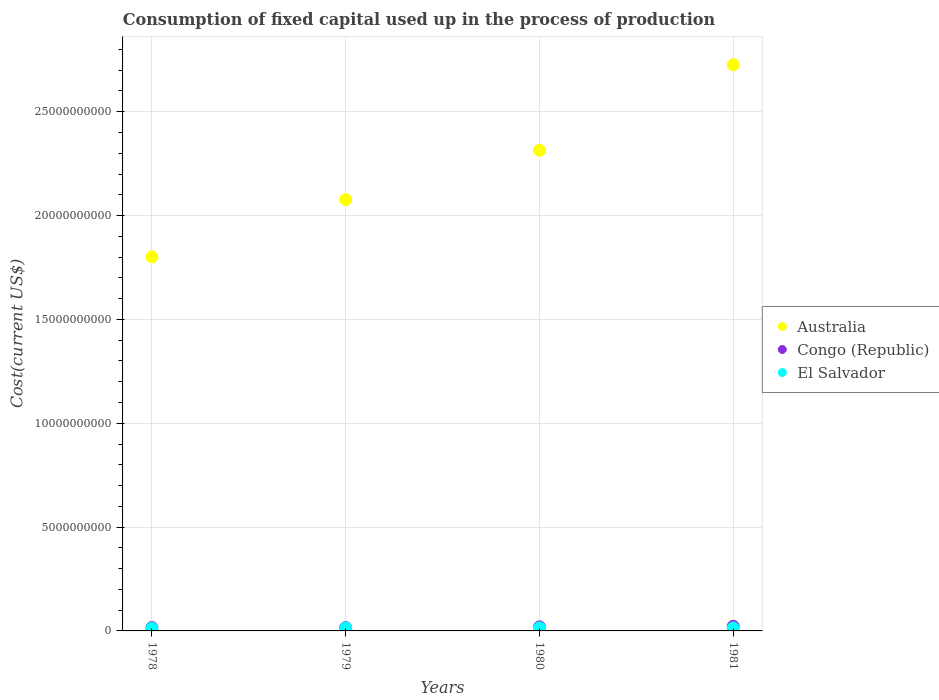Is the number of dotlines equal to the number of legend labels?
Ensure brevity in your answer.  Yes. What is the amount consumed in the process of production in Australia in 1980?
Your answer should be very brief. 2.31e+1. Across all years, what is the maximum amount consumed in the process of production in Australia?
Offer a terse response. 2.73e+1. Across all years, what is the minimum amount consumed in the process of production in Congo (Republic)?
Offer a very short reply. 1.60e+08. In which year was the amount consumed in the process of production in Australia maximum?
Keep it short and to the point. 1981. In which year was the amount consumed in the process of production in El Salvador minimum?
Keep it short and to the point. 1978. What is the total amount consumed in the process of production in Australia in the graph?
Make the answer very short. 8.92e+1. What is the difference between the amount consumed in the process of production in El Salvador in 1979 and that in 1980?
Keep it short and to the point. -4.63e+06. What is the difference between the amount consumed in the process of production in Congo (Republic) in 1981 and the amount consumed in the process of production in Australia in 1980?
Give a very brief answer. -2.29e+1. What is the average amount consumed in the process of production in Australia per year?
Make the answer very short. 2.23e+1. In the year 1979, what is the difference between the amount consumed in the process of production in El Salvador and amount consumed in the process of production in Congo (Republic)?
Provide a succinct answer. -1.71e+07. In how many years, is the amount consumed in the process of production in Australia greater than 10000000000 US$?
Your answer should be compact. 4. What is the ratio of the amount consumed in the process of production in El Salvador in 1978 to that in 1980?
Ensure brevity in your answer.  0.87. Is the difference between the amount consumed in the process of production in El Salvador in 1978 and 1980 greater than the difference between the amount consumed in the process of production in Congo (Republic) in 1978 and 1980?
Make the answer very short. Yes. What is the difference between the highest and the second highest amount consumed in the process of production in El Salvador?
Make the answer very short. 4.63e+06. What is the difference between the highest and the lowest amount consumed in the process of production in Australia?
Provide a short and direct response. 9.25e+09. In how many years, is the amount consumed in the process of production in El Salvador greater than the average amount consumed in the process of production in El Salvador taken over all years?
Provide a short and direct response. 3. Is it the case that in every year, the sum of the amount consumed in the process of production in Congo (Republic) and amount consumed in the process of production in El Salvador  is greater than the amount consumed in the process of production in Australia?
Offer a terse response. No. Is the amount consumed in the process of production in Australia strictly greater than the amount consumed in the process of production in El Salvador over the years?
Ensure brevity in your answer.  Yes. Is the amount consumed in the process of production in Australia strictly less than the amount consumed in the process of production in Congo (Republic) over the years?
Provide a short and direct response. No. How many years are there in the graph?
Provide a short and direct response. 4. Does the graph contain any zero values?
Make the answer very short. No. Where does the legend appear in the graph?
Offer a very short reply. Center right. How many legend labels are there?
Make the answer very short. 3. What is the title of the graph?
Keep it short and to the point. Consumption of fixed capital used up in the process of production. Does "East Asia (developing only)" appear as one of the legend labels in the graph?
Provide a short and direct response. No. What is the label or title of the Y-axis?
Your answer should be very brief. Cost(current US$). What is the Cost(current US$) in Australia in 1978?
Ensure brevity in your answer.  1.80e+1. What is the Cost(current US$) in Congo (Republic) in 1978?
Provide a short and direct response. 1.62e+08. What is the Cost(current US$) of El Salvador in 1978?
Your answer should be very brief. 1.29e+08. What is the Cost(current US$) in Australia in 1979?
Your answer should be compact. 2.08e+1. What is the Cost(current US$) in Congo (Republic) in 1979?
Your answer should be compact. 1.60e+08. What is the Cost(current US$) in El Salvador in 1979?
Your response must be concise. 1.43e+08. What is the Cost(current US$) in Australia in 1980?
Keep it short and to the point. 2.31e+1. What is the Cost(current US$) in Congo (Republic) in 1980?
Keep it short and to the point. 1.95e+08. What is the Cost(current US$) of El Salvador in 1980?
Make the answer very short. 1.48e+08. What is the Cost(current US$) of Australia in 1981?
Give a very brief answer. 2.73e+1. What is the Cost(current US$) in Congo (Republic) in 1981?
Offer a very short reply. 2.22e+08. What is the Cost(current US$) of El Salvador in 1981?
Offer a very short reply. 1.42e+08. Across all years, what is the maximum Cost(current US$) of Australia?
Provide a succinct answer. 2.73e+1. Across all years, what is the maximum Cost(current US$) in Congo (Republic)?
Provide a succinct answer. 2.22e+08. Across all years, what is the maximum Cost(current US$) of El Salvador?
Your answer should be compact. 1.48e+08. Across all years, what is the minimum Cost(current US$) in Australia?
Provide a short and direct response. 1.80e+1. Across all years, what is the minimum Cost(current US$) in Congo (Republic)?
Ensure brevity in your answer.  1.60e+08. Across all years, what is the minimum Cost(current US$) in El Salvador?
Your response must be concise. 1.29e+08. What is the total Cost(current US$) in Australia in the graph?
Give a very brief answer. 8.92e+1. What is the total Cost(current US$) of Congo (Republic) in the graph?
Your response must be concise. 7.39e+08. What is the total Cost(current US$) in El Salvador in the graph?
Your answer should be very brief. 5.63e+08. What is the difference between the Cost(current US$) in Australia in 1978 and that in 1979?
Provide a succinct answer. -2.76e+09. What is the difference between the Cost(current US$) in Congo (Republic) in 1978 and that in 1979?
Make the answer very short. 1.49e+06. What is the difference between the Cost(current US$) of El Salvador in 1978 and that in 1979?
Your response must be concise. -1.39e+07. What is the difference between the Cost(current US$) of Australia in 1978 and that in 1980?
Your response must be concise. -5.13e+09. What is the difference between the Cost(current US$) in Congo (Republic) in 1978 and that in 1980?
Your answer should be compact. -3.33e+07. What is the difference between the Cost(current US$) of El Salvador in 1978 and that in 1980?
Offer a terse response. -1.86e+07. What is the difference between the Cost(current US$) of Australia in 1978 and that in 1981?
Make the answer very short. -9.25e+09. What is the difference between the Cost(current US$) in Congo (Republic) in 1978 and that in 1981?
Give a very brief answer. -6.03e+07. What is the difference between the Cost(current US$) of El Salvador in 1978 and that in 1981?
Provide a succinct answer. -1.30e+07. What is the difference between the Cost(current US$) in Australia in 1979 and that in 1980?
Make the answer very short. -2.37e+09. What is the difference between the Cost(current US$) of Congo (Republic) in 1979 and that in 1980?
Make the answer very short. -3.48e+07. What is the difference between the Cost(current US$) of El Salvador in 1979 and that in 1980?
Provide a short and direct response. -4.63e+06. What is the difference between the Cost(current US$) in Australia in 1979 and that in 1981?
Offer a terse response. -6.49e+09. What is the difference between the Cost(current US$) of Congo (Republic) in 1979 and that in 1981?
Make the answer very short. -6.18e+07. What is the difference between the Cost(current US$) in El Salvador in 1979 and that in 1981?
Provide a short and direct response. 9.56e+05. What is the difference between the Cost(current US$) of Australia in 1980 and that in 1981?
Keep it short and to the point. -4.12e+09. What is the difference between the Cost(current US$) in Congo (Republic) in 1980 and that in 1981?
Make the answer very short. -2.69e+07. What is the difference between the Cost(current US$) of El Salvador in 1980 and that in 1981?
Give a very brief answer. 5.59e+06. What is the difference between the Cost(current US$) in Australia in 1978 and the Cost(current US$) in Congo (Republic) in 1979?
Your answer should be very brief. 1.79e+1. What is the difference between the Cost(current US$) of Australia in 1978 and the Cost(current US$) of El Salvador in 1979?
Your answer should be very brief. 1.79e+1. What is the difference between the Cost(current US$) in Congo (Republic) in 1978 and the Cost(current US$) in El Salvador in 1979?
Your answer should be very brief. 1.86e+07. What is the difference between the Cost(current US$) of Australia in 1978 and the Cost(current US$) of Congo (Republic) in 1980?
Ensure brevity in your answer.  1.78e+1. What is the difference between the Cost(current US$) of Australia in 1978 and the Cost(current US$) of El Salvador in 1980?
Provide a short and direct response. 1.79e+1. What is the difference between the Cost(current US$) of Congo (Republic) in 1978 and the Cost(current US$) of El Salvador in 1980?
Ensure brevity in your answer.  1.39e+07. What is the difference between the Cost(current US$) in Australia in 1978 and the Cost(current US$) in Congo (Republic) in 1981?
Offer a terse response. 1.78e+1. What is the difference between the Cost(current US$) in Australia in 1978 and the Cost(current US$) in El Salvador in 1981?
Make the answer very short. 1.79e+1. What is the difference between the Cost(current US$) of Congo (Republic) in 1978 and the Cost(current US$) of El Salvador in 1981?
Give a very brief answer. 1.95e+07. What is the difference between the Cost(current US$) in Australia in 1979 and the Cost(current US$) in Congo (Republic) in 1980?
Offer a terse response. 2.06e+1. What is the difference between the Cost(current US$) of Australia in 1979 and the Cost(current US$) of El Salvador in 1980?
Ensure brevity in your answer.  2.06e+1. What is the difference between the Cost(current US$) of Congo (Republic) in 1979 and the Cost(current US$) of El Salvador in 1980?
Your response must be concise. 1.24e+07. What is the difference between the Cost(current US$) of Australia in 1979 and the Cost(current US$) of Congo (Republic) in 1981?
Offer a very short reply. 2.05e+1. What is the difference between the Cost(current US$) of Australia in 1979 and the Cost(current US$) of El Salvador in 1981?
Your answer should be very brief. 2.06e+1. What is the difference between the Cost(current US$) of Congo (Republic) in 1979 and the Cost(current US$) of El Salvador in 1981?
Your answer should be compact. 1.80e+07. What is the difference between the Cost(current US$) in Australia in 1980 and the Cost(current US$) in Congo (Republic) in 1981?
Make the answer very short. 2.29e+1. What is the difference between the Cost(current US$) of Australia in 1980 and the Cost(current US$) of El Salvador in 1981?
Your answer should be compact. 2.30e+1. What is the difference between the Cost(current US$) of Congo (Republic) in 1980 and the Cost(current US$) of El Salvador in 1981?
Provide a succinct answer. 5.29e+07. What is the average Cost(current US$) in Australia per year?
Offer a very short reply. 2.23e+1. What is the average Cost(current US$) in Congo (Republic) per year?
Your response must be concise. 1.85e+08. What is the average Cost(current US$) of El Salvador per year?
Give a very brief answer. 1.41e+08. In the year 1978, what is the difference between the Cost(current US$) in Australia and Cost(current US$) in Congo (Republic)?
Offer a very short reply. 1.78e+1. In the year 1978, what is the difference between the Cost(current US$) in Australia and Cost(current US$) in El Salvador?
Give a very brief answer. 1.79e+1. In the year 1978, what is the difference between the Cost(current US$) of Congo (Republic) and Cost(current US$) of El Salvador?
Offer a terse response. 3.25e+07. In the year 1979, what is the difference between the Cost(current US$) of Australia and Cost(current US$) of Congo (Republic)?
Ensure brevity in your answer.  2.06e+1. In the year 1979, what is the difference between the Cost(current US$) in Australia and Cost(current US$) in El Salvador?
Your answer should be very brief. 2.06e+1. In the year 1979, what is the difference between the Cost(current US$) in Congo (Republic) and Cost(current US$) in El Salvador?
Keep it short and to the point. 1.71e+07. In the year 1980, what is the difference between the Cost(current US$) in Australia and Cost(current US$) in Congo (Republic)?
Keep it short and to the point. 2.29e+1. In the year 1980, what is the difference between the Cost(current US$) of Australia and Cost(current US$) of El Salvador?
Provide a short and direct response. 2.30e+1. In the year 1980, what is the difference between the Cost(current US$) of Congo (Republic) and Cost(current US$) of El Salvador?
Ensure brevity in your answer.  4.73e+07. In the year 1981, what is the difference between the Cost(current US$) of Australia and Cost(current US$) of Congo (Republic)?
Offer a terse response. 2.70e+1. In the year 1981, what is the difference between the Cost(current US$) in Australia and Cost(current US$) in El Salvador?
Make the answer very short. 2.71e+1. In the year 1981, what is the difference between the Cost(current US$) in Congo (Republic) and Cost(current US$) in El Salvador?
Offer a very short reply. 7.98e+07. What is the ratio of the Cost(current US$) of Australia in 1978 to that in 1979?
Keep it short and to the point. 0.87. What is the ratio of the Cost(current US$) in Congo (Republic) in 1978 to that in 1979?
Offer a very short reply. 1.01. What is the ratio of the Cost(current US$) of El Salvador in 1978 to that in 1979?
Give a very brief answer. 0.9. What is the ratio of the Cost(current US$) in Australia in 1978 to that in 1980?
Provide a short and direct response. 0.78. What is the ratio of the Cost(current US$) of Congo (Republic) in 1978 to that in 1980?
Give a very brief answer. 0.83. What is the ratio of the Cost(current US$) of El Salvador in 1978 to that in 1980?
Your answer should be very brief. 0.87. What is the ratio of the Cost(current US$) of Australia in 1978 to that in 1981?
Provide a short and direct response. 0.66. What is the ratio of the Cost(current US$) of Congo (Republic) in 1978 to that in 1981?
Offer a very short reply. 0.73. What is the ratio of the Cost(current US$) of El Salvador in 1978 to that in 1981?
Ensure brevity in your answer.  0.91. What is the ratio of the Cost(current US$) in Australia in 1979 to that in 1980?
Your answer should be very brief. 0.9. What is the ratio of the Cost(current US$) of Congo (Republic) in 1979 to that in 1980?
Keep it short and to the point. 0.82. What is the ratio of the Cost(current US$) in El Salvador in 1979 to that in 1980?
Your answer should be very brief. 0.97. What is the ratio of the Cost(current US$) of Australia in 1979 to that in 1981?
Give a very brief answer. 0.76. What is the ratio of the Cost(current US$) of Congo (Republic) in 1979 to that in 1981?
Your answer should be very brief. 0.72. What is the ratio of the Cost(current US$) of El Salvador in 1979 to that in 1981?
Provide a succinct answer. 1.01. What is the ratio of the Cost(current US$) in Australia in 1980 to that in 1981?
Offer a terse response. 0.85. What is the ratio of the Cost(current US$) in Congo (Republic) in 1980 to that in 1981?
Offer a terse response. 0.88. What is the ratio of the Cost(current US$) in El Salvador in 1980 to that in 1981?
Give a very brief answer. 1.04. What is the difference between the highest and the second highest Cost(current US$) in Australia?
Your answer should be very brief. 4.12e+09. What is the difference between the highest and the second highest Cost(current US$) of Congo (Republic)?
Offer a terse response. 2.69e+07. What is the difference between the highest and the second highest Cost(current US$) of El Salvador?
Provide a short and direct response. 4.63e+06. What is the difference between the highest and the lowest Cost(current US$) of Australia?
Your answer should be compact. 9.25e+09. What is the difference between the highest and the lowest Cost(current US$) in Congo (Republic)?
Keep it short and to the point. 6.18e+07. What is the difference between the highest and the lowest Cost(current US$) in El Salvador?
Your answer should be very brief. 1.86e+07. 